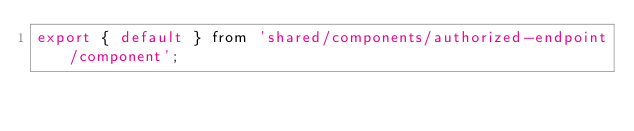Convert code to text. <code><loc_0><loc_0><loc_500><loc_500><_JavaScript_>export { default } from 'shared/components/authorized-endpoint/component';</code> 